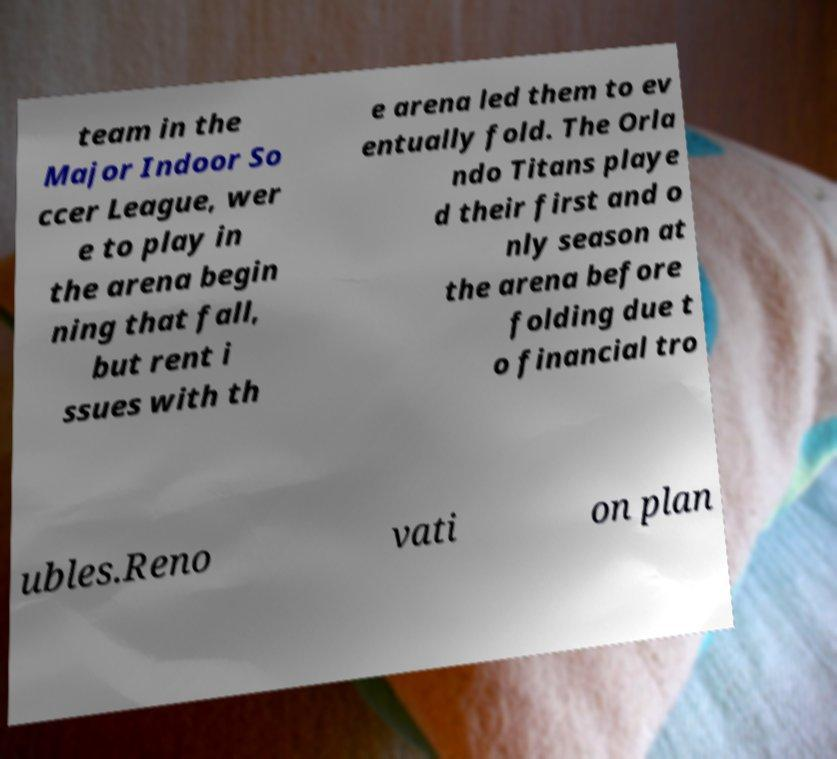Can you accurately transcribe the text from the provided image for me? team in the Major Indoor So ccer League, wer e to play in the arena begin ning that fall, but rent i ssues with th e arena led them to ev entually fold. The Orla ndo Titans playe d their first and o nly season at the arena before folding due t o financial tro ubles.Reno vati on plan 